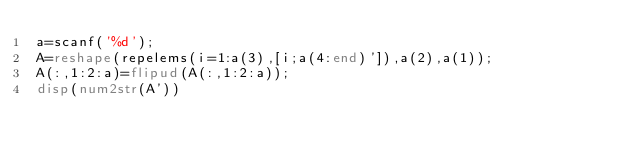<code> <loc_0><loc_0><loc_500><loc_500><_Octave_>a=scanf('%d');
A=reshape(repelems(i=1:a(3),[i;a(4:end)']),a(2),a(1));
A(:,1:2:a)=flipud(A(:,1:2:a));
disp(num2str(A'))</code> 